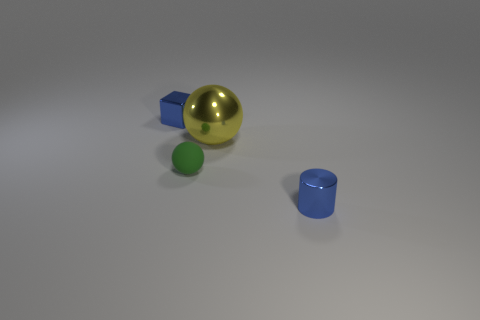Does the yellow metallic object behind the tiny green sphere have the same shape as the matte object?
Offer a terse response. Yes. How many metallic objects are tiny green spheres or small brown objects?
Your answer should be compact. 0. Are there any small blocks that have the same material as the small blue cylinder?
Ensure brevity in your answer.  Yes. What material is the tiny cube?
Provide a succinct answer. Metal. What is the shape of the small green rubber object that is on the right side of the small shiny object left of the metal object in front of the big metallic object?
Give a very brief answer. Sphere. Is the number of blue objects that are behind the green ball greater than the number of blue metallic balls?
Your answer should be compact. Yes. Does the tiny green object have the same shape as the small thing that is in front of the tiny green rubber object?
Your response must be concise. No. There is a object that is the same color as the tiny shiny cylinder; what is its shape?
Provide a short and direct response. Cube. There is a tiny blue shiny thing in front of the tiny metal object that is left of the small metallic cylinder; how many large spheres are on the right side of it?
Keep it short and to the point. 0. The cube that is the same size as the green rubber object is what color?
Your answer should be very brief. Blue. 